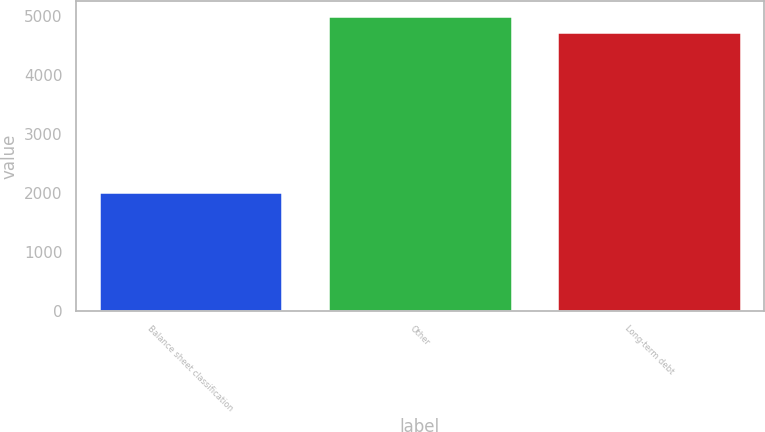Convert chart to OTSL. <chart><loc_0><loc_0><loc_500><loc_500><bar_chart><fcel>Balance sheet classification<fcel>Other<fcel>Long-term debt<nl><fcel>2013<fcel>5000.3<fcel>4724<nl></chart> 